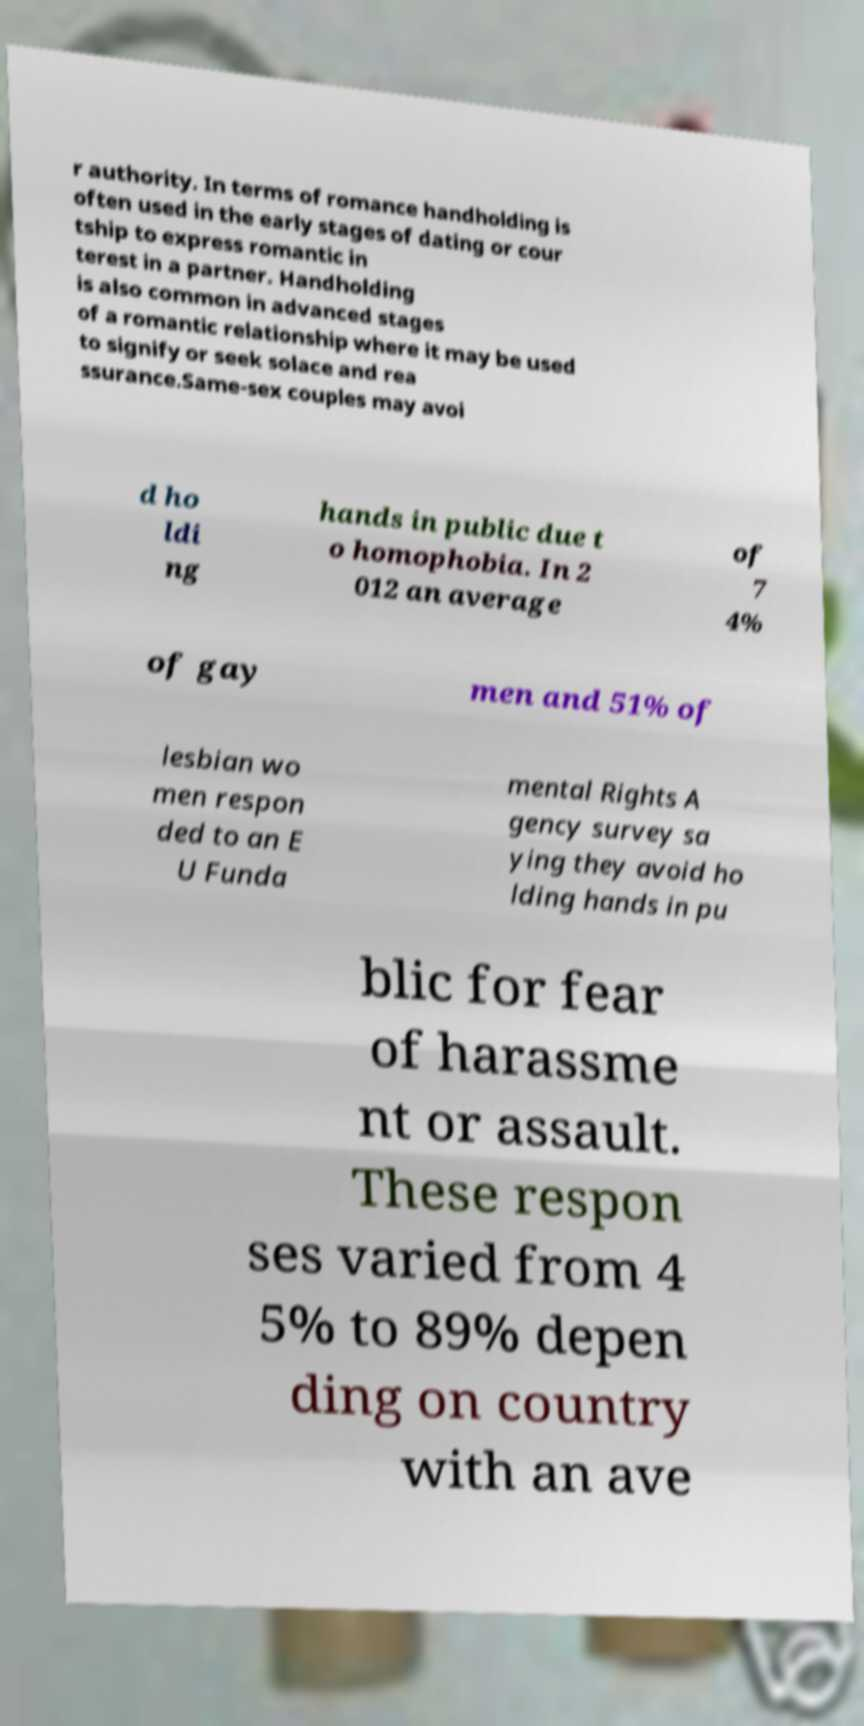Please identify and transcribe the text found in this image. r authority. In terms of romance handholding is often used in the early stages of dating or cour tship to express romantic in terest in a partner. Handholding is also common in advanced stages of a romantic relationship where it may be used to signify or seek solace and rea ssurance.Same-sex couples may avoi d ho ldi ng hands in public due t o homophobia. In 2 012 an average of 7 4% of gay men and 51% of lesbian wo men respon ded to an E U Funda mental Rights A gency survey sa ying they avoid ho lding hands in pu blic for fear of harassme nt or assault. These respon ses varied from 4 5% to 89% depen ding on country with an ave 